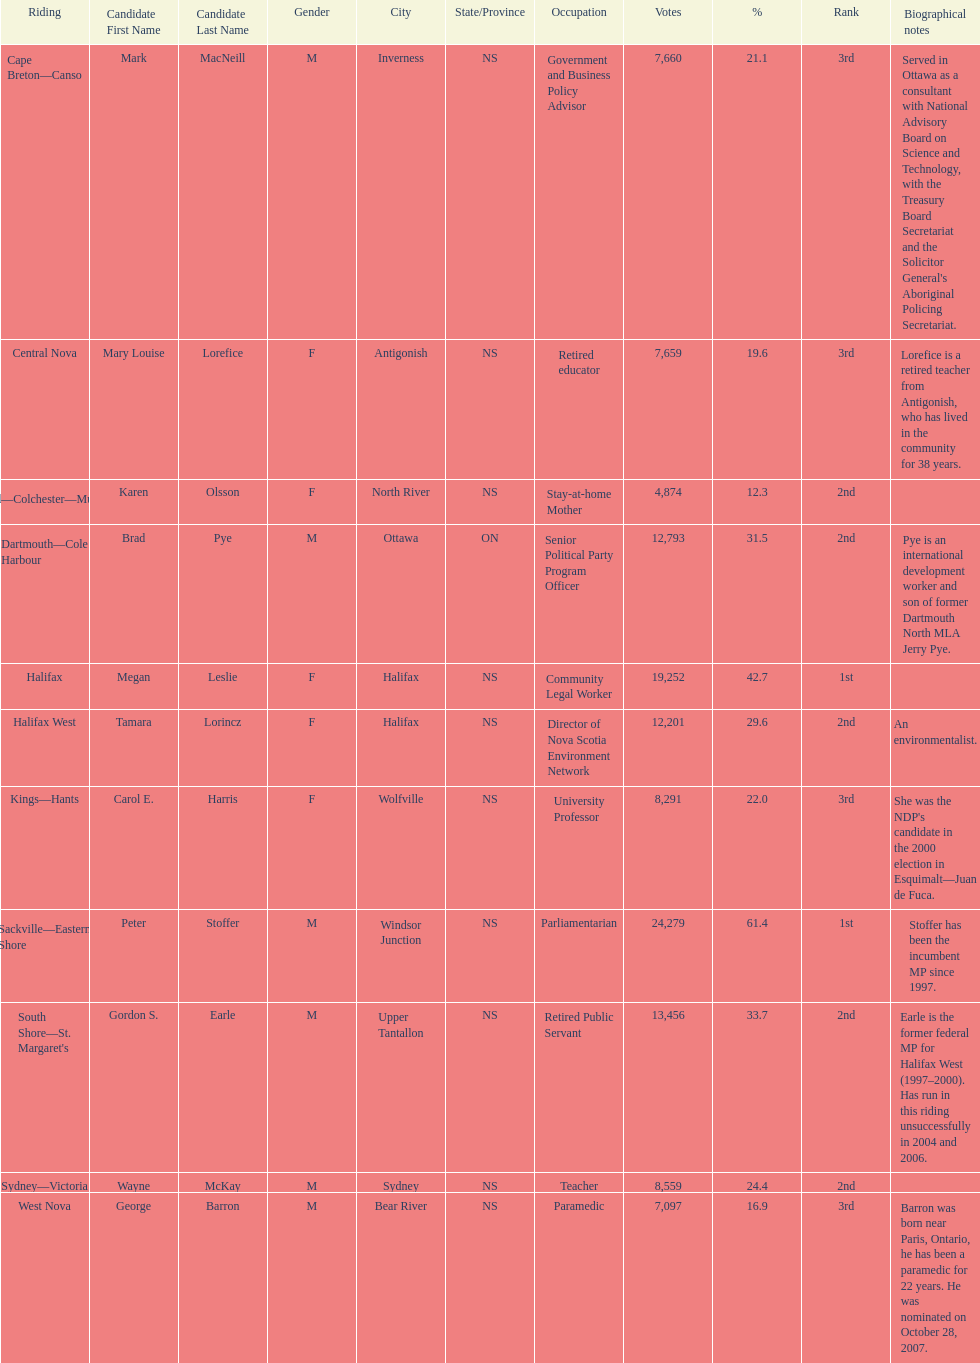Tell me the total number of votes the female candidates got. 52,277. Parse the table in full. {'header': ['Riding', 'Candidate First Name', 'Candidate Last Name', 'Gender', 'City', 'State/Province', 'Occupation', 'Votes', '%', 'Rank', 'Biographical notes'], 'rows': [['Cape Breton—Canso', 'Mark', 'MacNeill', 'M', 'Inverness', 'NS', 'Government and Business Policy Advisor', '7,660', '21.1', '3rd', "Served in Ottawa as a consultant with National Advisory Board on Science and Technology, with the Treasury Board Secretariat and the Solicitor General's Aboriginal Policing Secretariat."], ['Central Nova', 'Mary Louise', 'Lorefice', 'F', 'Antigonish', 'NS', 'Retired educator', '7,659', '19.6', '3rd', 'Lorefice is a retired teacher from Antigonish, who has lived in the community for 38 years.'], ['Cumberland—Colchester—Musquodoboit Valley', 'Karen', 'Olsson', 'F', 'North River', 'NS', 'Stay-at-home Mother', '4,874', '12.3', '2nd', ''], ['Dartmouth—Cole Harbour', 'Brad', 'Pye', 'M', 'Ottawa', 'ON', 'Senior Political Party Program Officer', '12,793', '31.5', '2nd', 'Pye is an international development worker and son of former Dartmouth North MLA Jerry Pye.'], ['Halifax', 'Megan', 'Leslie', 'F', 'Halifax', 'NS', 'Community Legal Worker', '19,252', '42.7', '1st', ''], ['Halifax West', 'Tamara', 'Lorincz', 'F', 'Halifax', 'NS', 'Director of Nova Scotia Environment Network', '12,201', '29.6', '2nd', 'An environmentalist.'], ['Kings—Hants', 'Carol E.', 'Harris', 'F', 'Wolfville', 'NS', 'University Professor', '8,291', '22.0', '3rd', "She was the NDP's candidate in the 2000 election in Esquimalt—Juan de Fuca."], ['Sackville—Eastern Shore', 'Peter', 'Stoffer', 'M', 'Windsor Junction', 'NS', 'Parliamentarian', '24,279', '61.4', '1st', 'Stoffer has been the incumbent MP since 1997.'], ["South Shore—St. Margaret's", 'Gordon S.', 'Earle', 'M', 'Upper Tantallon', 'NS', 'Retired Public Servant', '13,456', '33.7', '2nd', 'Earle is the former federal MP for Halifax West (1997–2000). Has run in this riding unsuccessfully in 2004 and 2006.'], ['Sydney—Victoria', 'Wayne', 'McKay', 'M', 'Sydney', 'NS', 'Teacher', '8,559', '24.4', '2nd', ''], ['West Nova', 'George', 'Barron', 'M', 'Bear River', 'NS', 'Paramedic', '7,097', '16.9', '3rd', 'Barron was born near Paris, Ontario, he has been a paramedic for 22 years. He was nominated on October 28, 2007.']]} 